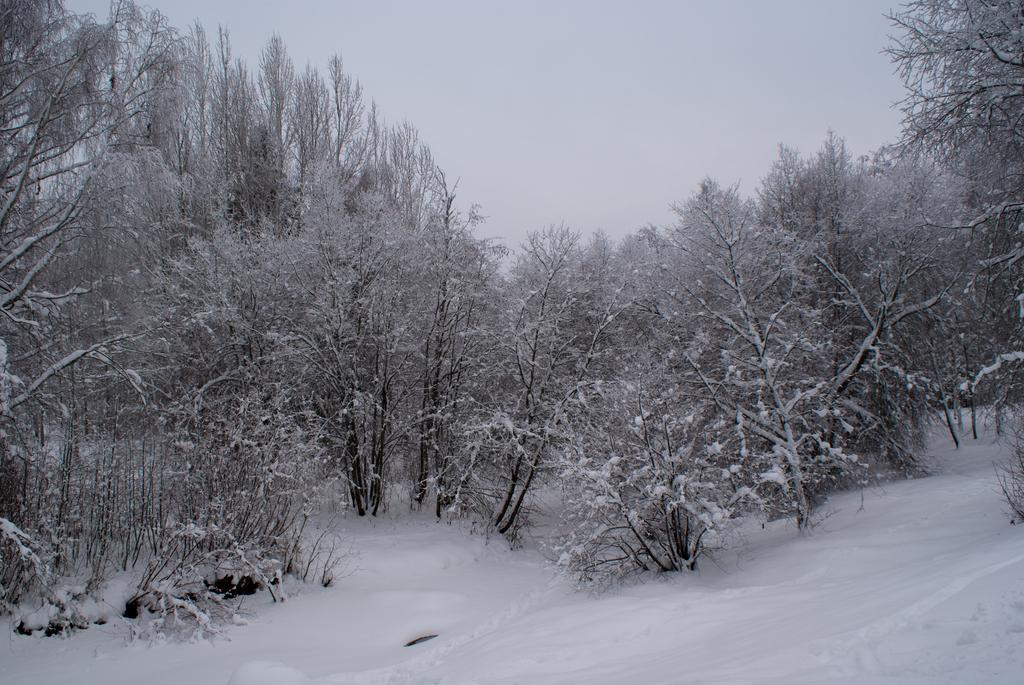What type of environment is depicted in the image? The image appears to be taken in a forest. What can be seen in the background of the image? There are trees in the background of the image. What is covering the ground in the image? There is snow at the bottom of the image. What is visible at the top of the image? The sky is visible at the top of the image. What book is the actor holding in the image? There is no actor or book present in the image; it depicts a forest scene with snow on the ground. 